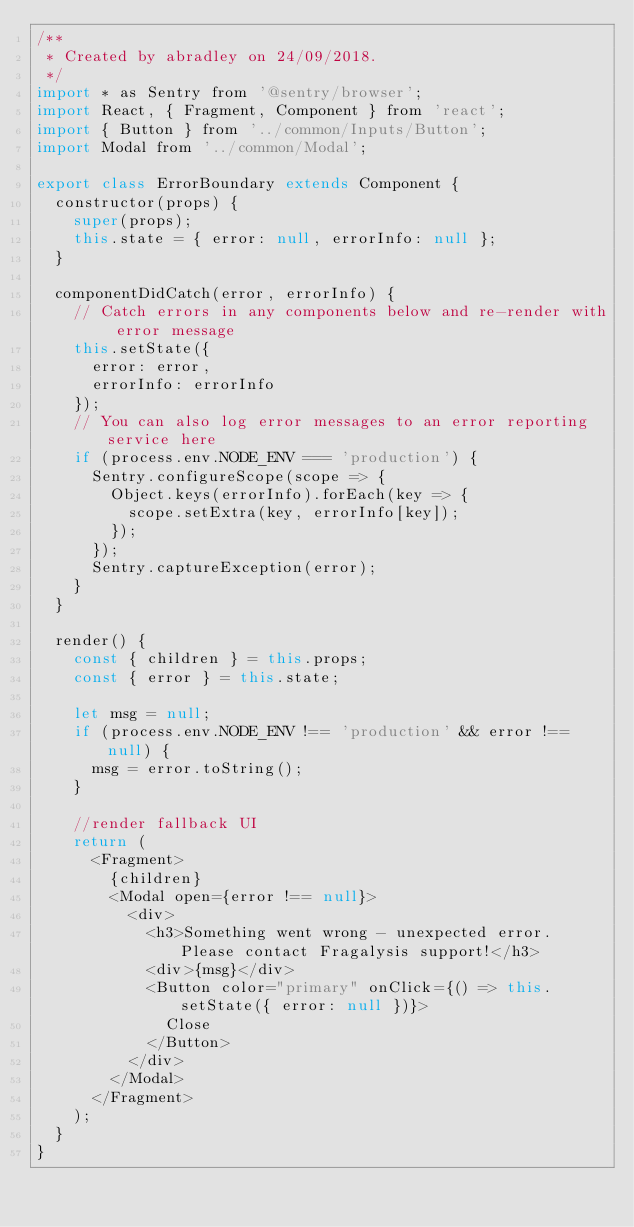Convert code to text. <code><loc_0><loc_0><loc_500><loc_500><_JavaScript_>/**
 * Created by abradley on 24/09/2018.
 */
import * as Sentry from '@sentry/browser';
import React, { Fragment, Component } from 'react';
import { Button } from '../common/Inputs/Button';
import Modal from '../common/Modal';

export class ErrorBoundary extends Component {
  constructor(props) {
    super(props);
    this.state = { error: null, errorInfo: null };
  }

  componentDidCatch(error, errorInfo) {
    // Catch errors in any components below and re-render with error message
    this.setState({
      error: error,
      errorInfo: errorInfo
    });
    // You can also log error messages to an error reporting service here
    if (process.env.NODE_ENV === 'production') {
      Sentry.configureScope(scope => {
        Object.keys(errorInfo).forEach(key => {
          scope.setExtra(key, errorInfo[key]);
        });
      });
      Sentry.captureException(error);
    }
  }

  render() {
    const { children } = this.props;
    const { error } = this.state;

    let msg = null;
    if (process.env.NODE_ENV !== 'production' && error !== null) {
      msg = error.toString();
    }

    //render fallback UI
    return (
      <Fragment>
        {children}
        <Modal open={error !== null}>
          <div>
            <h3>Something went wrong - unexpected error. Please contact Fragalysis support!</h3>
            <div>{msg}</div>
            <Button color="primary" onClick={() => this.setState({ error: null })}>
              Close
            </Button>
          </div>
        </Modal>
      </Fragment>
    );
  }
}
</code> 